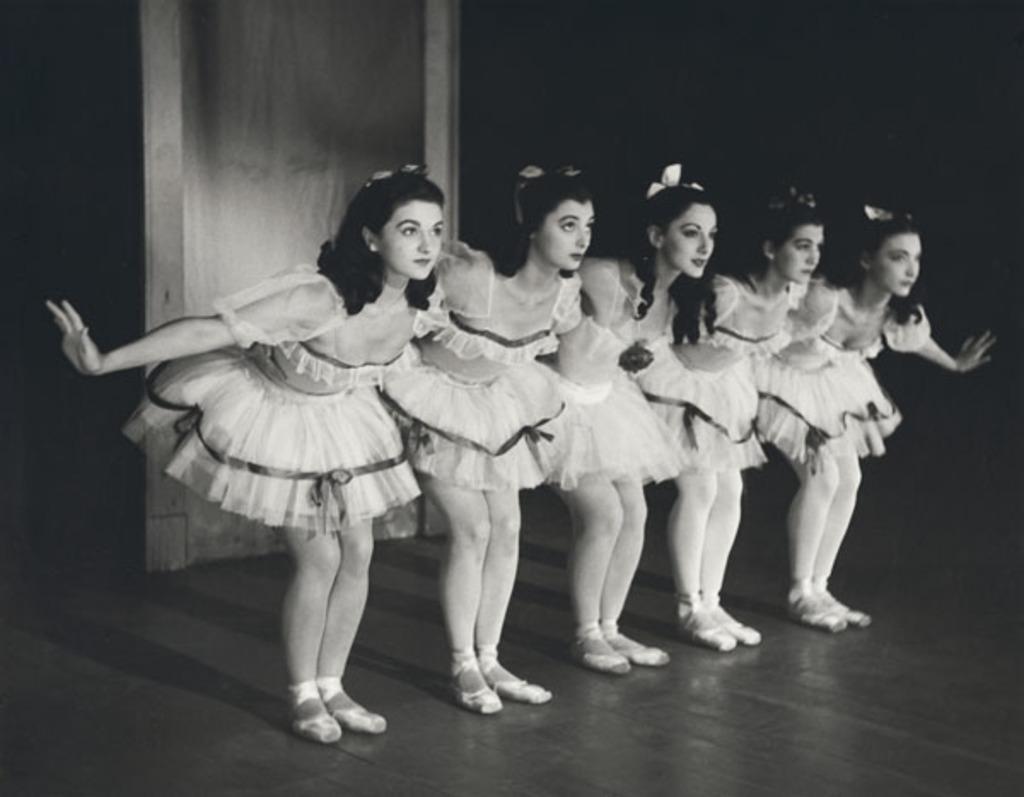Please provide a concise description of this image. In this image we can see a group of people are dancing on the stage. There is a wooden object in the image. 